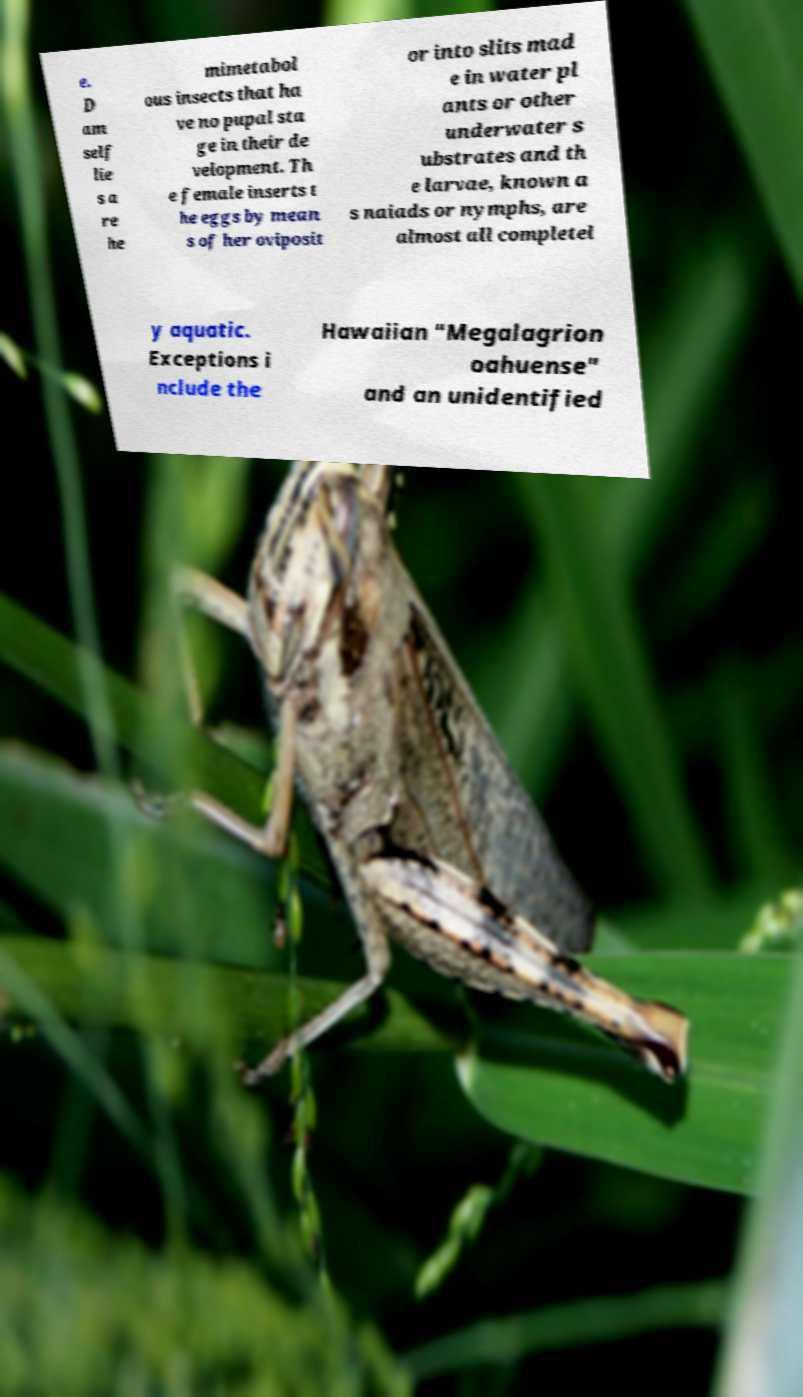There's text embedded in this image that I need extracted. Can you transcribe it verbatim? e. D am self lie s a re he mimetabol ous insects that ha ve no pupal sta ge in their de velopment. Th e female inserts t he eggs by mean s of her oviposit or into slits mad e in water pl ants or other underwater s ubstrates and th e larvae, known a s naiads or nymphs, are almost all completel y aquatic. Exceptions i nclude the Hawaiian "Megalagrion oahuense" and an unidentified 